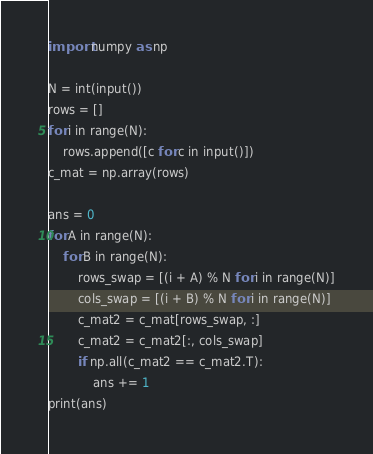Convert code to text. <code><loc_0><loc_0><loc_500><loc_500><_Python_>
import numpy as np

N = int(input())
rows = []
for i in range(N):
    rows.append([c for c in input()])
c_mat = np.array(rows)

ans = 0
for A in range(N):
    for B in range(N):
        rows_swap = [(i + A) % N for i in range(N)]
        cols_swap = [(i + B) % N for i in range(N)]
        c_mat2 = c_mat[rows_swap, :]
        c_mat2 = c_mat2[:, cols_swap]
        if np.all(c_mat2 == c_mat2.T):
            ans += 1
print(ans)
</code> 